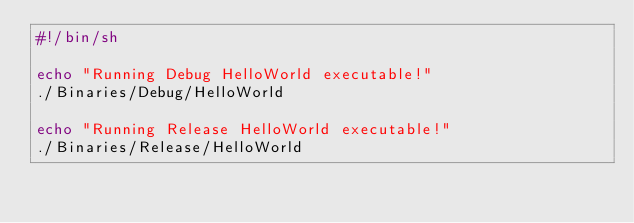Convert code to text. <code><loc_0><loc_0><loc_500><loc_500><_Bash_>#!/bin/sh

echo "Running Debug HelloWorld executable!"
./Binaries/Debug/HelloWorld

echo "Running Release HelloWorld executable!"
./Binaries/Release/HelloWorld</code> 